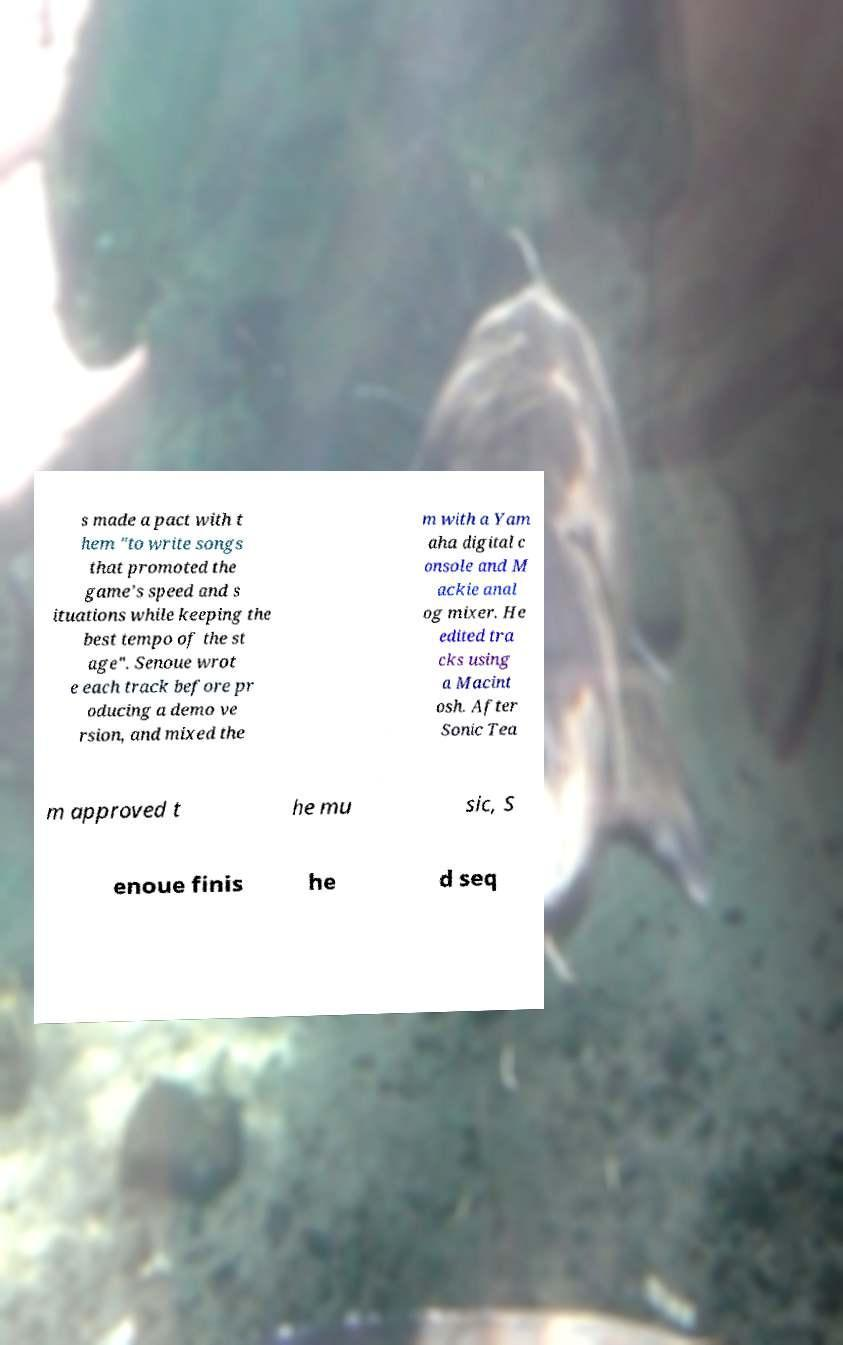For documentation purposes, I need the text within this image transcribed. Could you provide that? s made a pact with t hem "to write songs that promoted the game's speed and s ituations while keeping the best tempo of the st age". Senoue wrot e each track before pr oducing a demo ve rsion, and mixed the m with a Yam aha digital c onsole and M ackie anal og mixer. He edited tra cks using a Macint osh. After Sonic Tea m approved t he mu sic, S enoue finis he d seq 